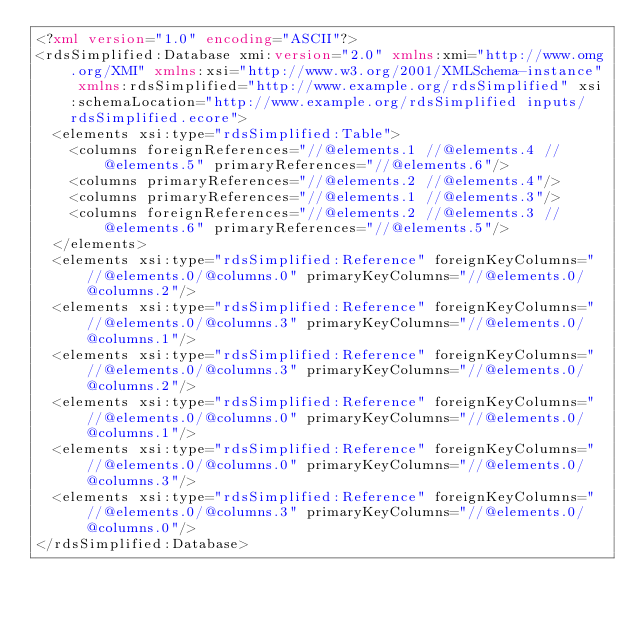Convert code to text. <code><loc_0><loc_0><loc_500><loc_500><_XML_><?xml version="1.0" encoding="ASCII"?>
<rdsSimplified:Database xmi:version="2.0" xmlns:xmi="http://www.omg.org/XMI" xmlns:xsi="http://www.w3.org/2001/XMLSchema-instance" xmlns:rdsSimplified="http://www.example.org/rdsSimplified" xsi:schemaLocation="http://www.example.org/rdsSimplified inputs/rdsSimplified.ecore">
  <elements xsi:type="rdsSimplified:Table">
    <columns foreignReferences="//@elements.1 //@elements.4 //@elements.5" primaryReferences="//@elements.6"/>
    <columns primaryReferences="//@elements.2 //@elements.4"/>
    <columns primaryReferences="//@elements.1 //@elements.3"/>
    <columns foreignReferences="//@elements.2 //@elements.3 //@elements.6" primaryReferences="//@elements.5"/>
  </elements>
  <elements xsi:type="rdsSimplified:Reference" foreignKeyColumns="//@elements.0/@columns.0" primaryKeyColumns="//@elements.0/@columns.2"/>
  <elements xsi:type="rdsSimplified:Reference" foreignKeyColumns="//@elements.0/@columns.3" primaryKeyColumns="//@elements.0/@columns.1"/>
  <elements xsi:type="rdsSimplified:Reference" foreignKeyColumns="//@elements.0/@columns.3" primaryKeyColumns="//@elements.0/@columns.2"/>
  <elements xsi:type="rdsSimplified:Reference" foreignKeyColumns="//@elements.0/@columns.0" primaryKeyColumns="//@elements.0/@columns.1"/>
  <elements xsi:type="rdsSimplified:Reference" foreignKeyColumns="//@elements.0/@columns.0" primaryKeyColumns="//@elements.0/@columns.3"/>
  <elements xsi:type="rdsSimplified:Reference" foreignKeyColumns="//@elements.0/@columns.3" primaryKeyColumns="//@elements.0/@columns.0"/>
</rdsSimplified:Database>
</code> 